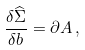<formula> <loc_0><loc_0><loc_500><loc_500>\frac { \delta \widehat { \Sigma } } { \delta b } = \partial A \, ,</formula> 